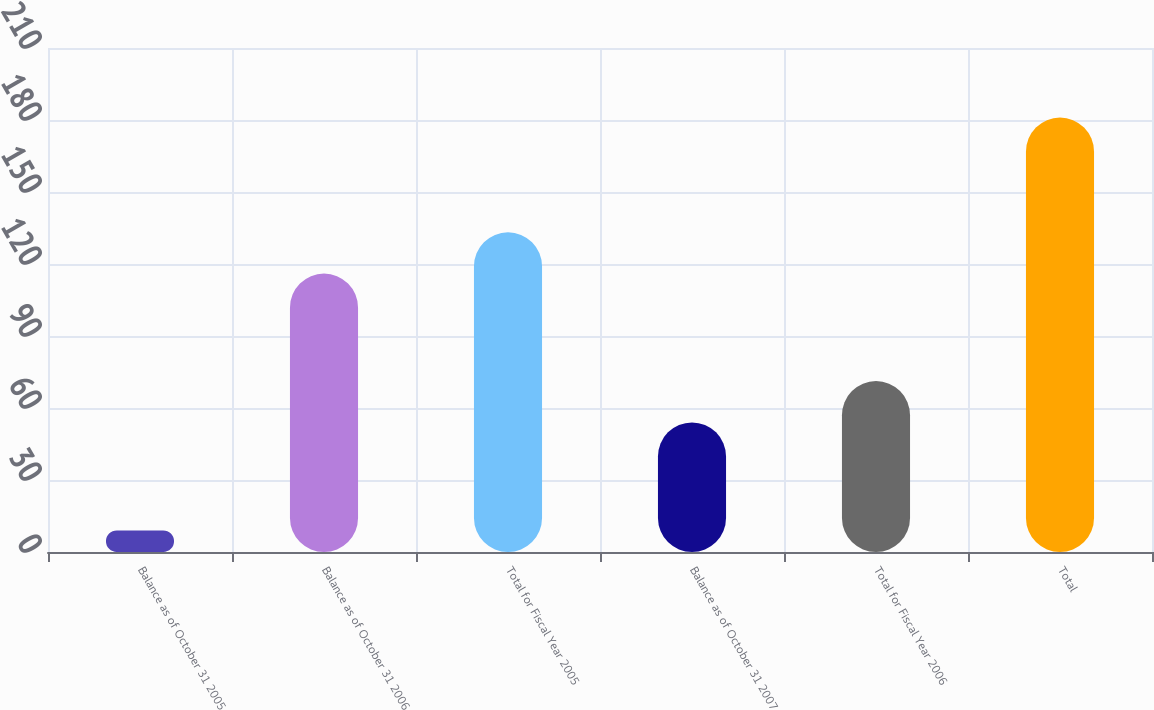Convert chart. <chart><loc_0><loc_0><loc_500><loc_500><bar_chart><fcel>Balance as of October 31 2005<fcel>Balance as of October 31 2006<fcel>Total for Fiscal Year 2005<fcel>Balance as of October 31 2007<fcel>Total for Fiscal Year 2006<fcel>Total<nl><fcel>9<fcel>116<fcel>133.2<fcel>54<fcel>71.2<fcel>181<nl></chart> 